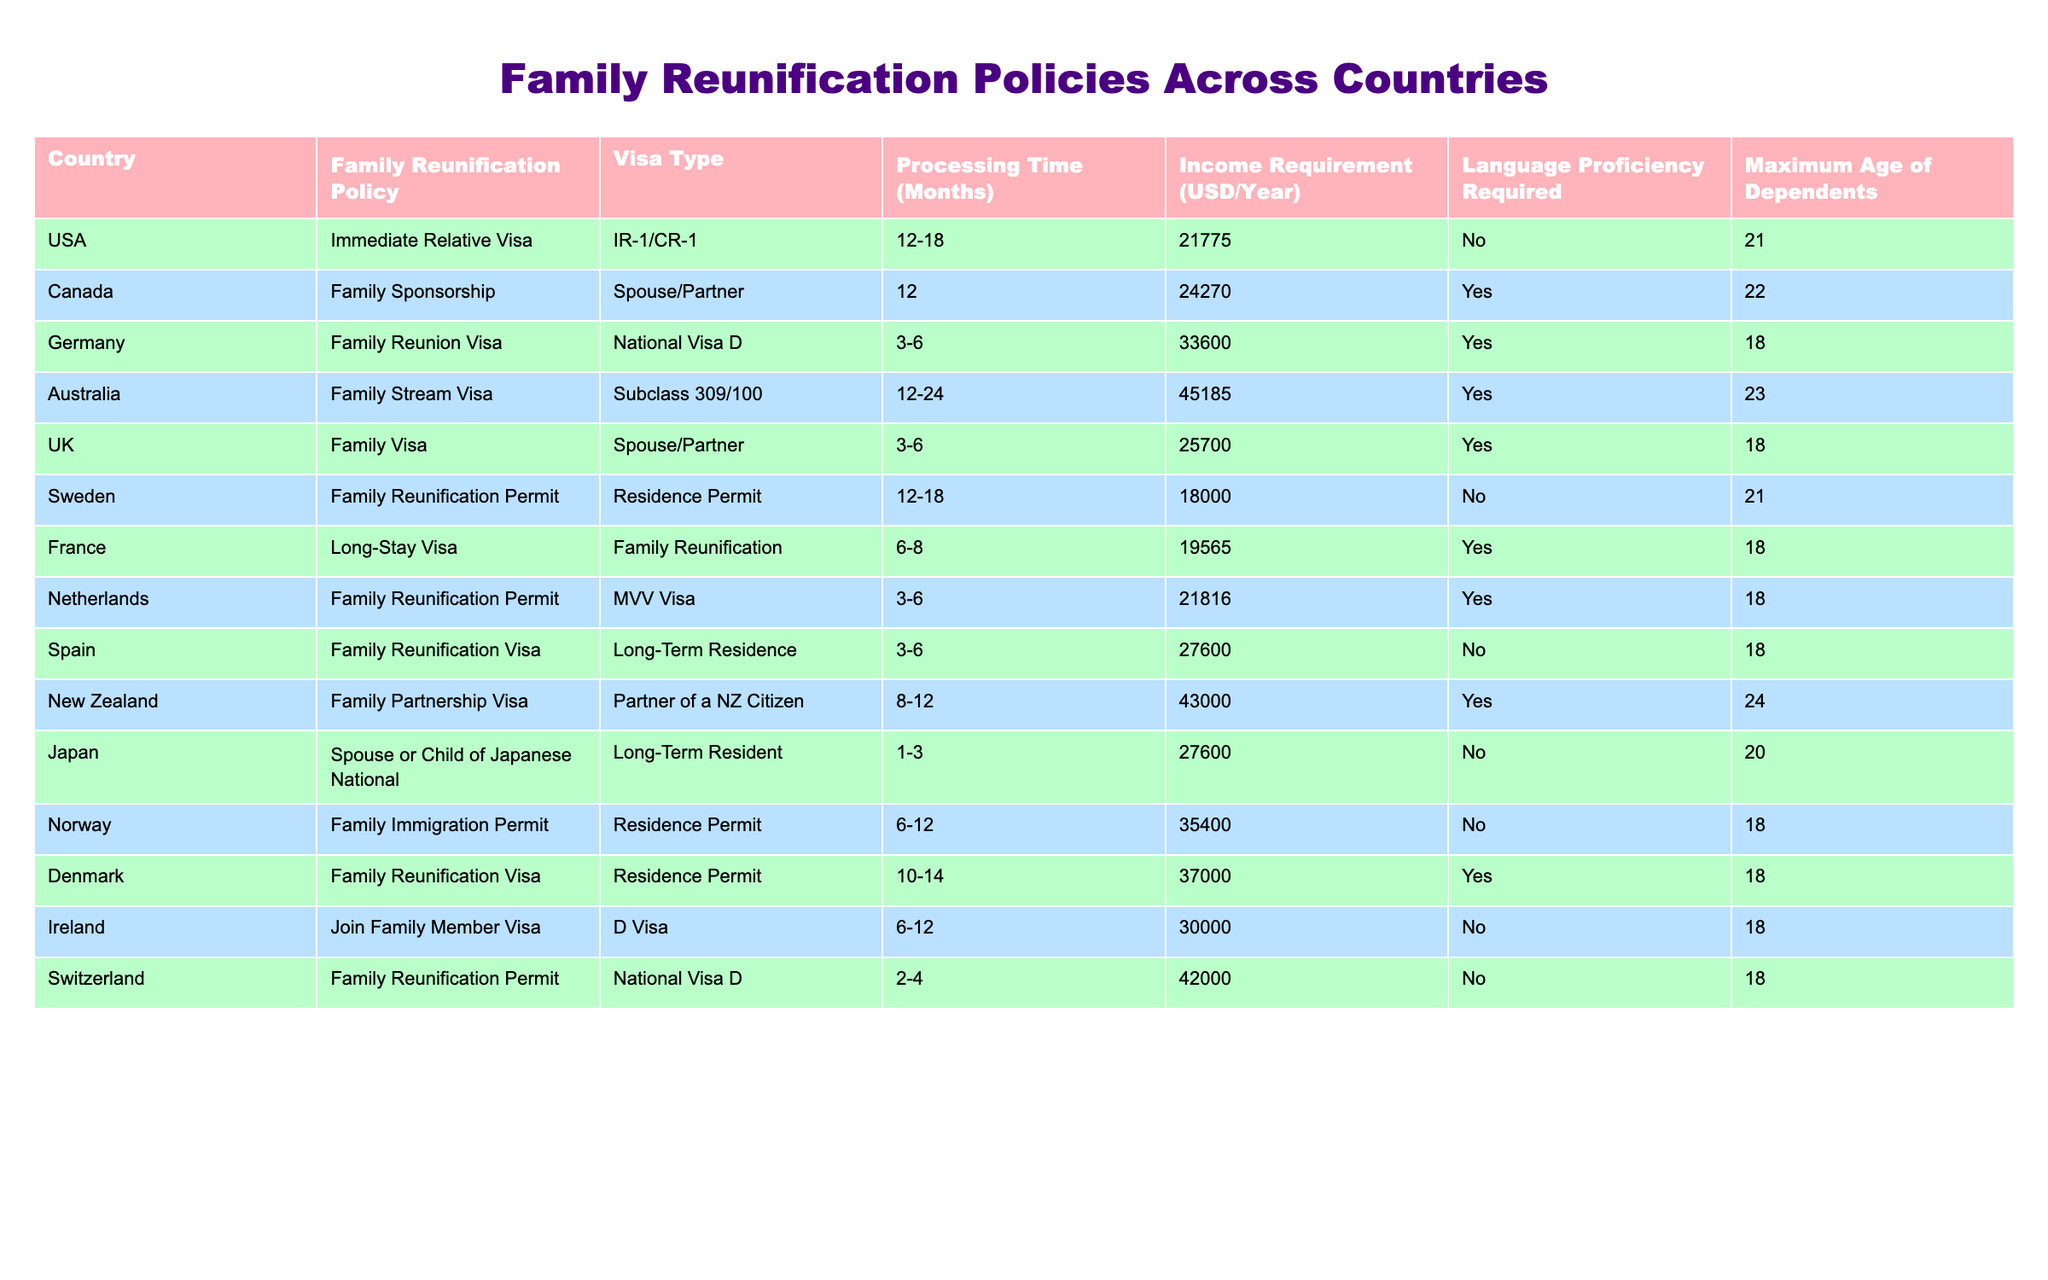What is the maximum age of dependents for the Family Reunification Visa in the UK? According to the table, the maximum age of dependents for the Family Visa in the UK is listed as 18 years.
Answer: 18 How many months does it take to process a Family Reunification Permit in Norway? The table states that the processing time for the Family Immigration Permit in Norway ranges from 6 to 12 months.
Answer: 6-12 Which country has the highest income requirement for family reunification, and what is it? By comparing the income requirements listed for each country, Australia has the highest income requirement of 45185 USD per year.
Answer: Australia, 45185 Is there a language proficiency requirement for the Family Reunification Permit in Sweden? The table indicates that there is no language proficiency requirement for the Family Reunification Permit in Sweden, as it states "No."
Answer: No What is the average processing time for family reunification visas across the listed countries? To find the average processing time, sum the midpoints of the processing ranges: USA (15), Canada (12), Germany (4.5), Australia (18), etc. The total is 66.5 months for 9 countries, giving an average of approximately 7.39 months.
Answer: Approximately 7.39 Which countries require income verification for family reunification, based on the table? The countries that require income verification are Canada, Germany, Australia, UK, France, Netherlands, New Zealand, and Denmark, as indicated by "Yes" in the income requirement column.
Answer: Canada, Germany, Australia, UK, France, Netherlands, New Zealand, Denmark How does the maximum age of dependents in Japan compare to that of other countries? The maximum age of dependents in Japan is 20 years, which is younger than several countries like USA, Australia, and Canada (21-24 years). It is equal to Japan but older than Finland and some others with 18 years.
Answer: 20 What percentage of the countries listed require a language proficiency for family reunification? Out of the 16 countries listed, 9 require language proficiency. This accounts for approximately 56.25% of the countries needing language verification (9/16 * 100).
Answer: 56.25% 